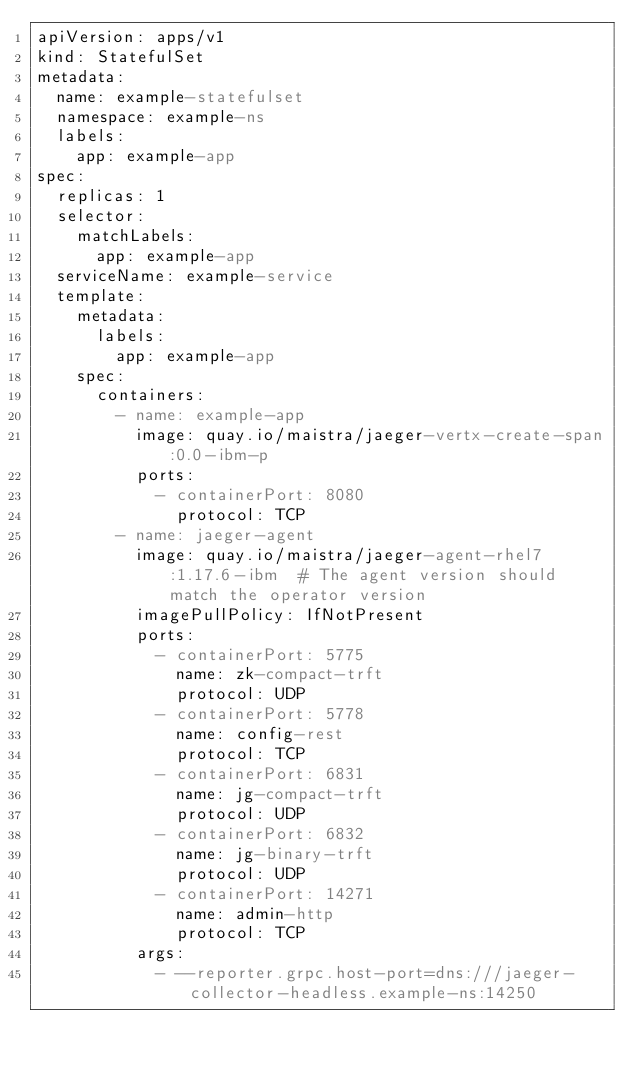Convert code to text. <code><loc_0><loc_0><loc_500><loc_500><_YAML_>apiVersion: apps/v1
kind: StatefulSet
metadata:
  name: example-statefulset
  namespace: example-ns
  labels:
    app: example-app
spec:
  replicas: 1
  selector:
    matchLabels:
      app: example-app
  serviceName: example-service
  template:
    metadata:
      labels:
        app: example-app
    spec:
      containers:
        - name: example-app
          image: quay.io/maistra/jaeger-vertx-create-span:0.0-ibm-p
          ports:
            - containerPort: 8080
              protocol: TCP
        - name: jaeger-agent
          image: quay.io/maistra/jaeger-agent-rhel7:1.17.6-ibm  # The agent version should match the operator version
          imagePullPolicy: IfNotPresent
          ports:
            - containerPort: 5775
              name: zk-compact-trft
              protocol: UDP
            - containerPort: 5778
              name: config-rest
              protocol: TCP
            - containerPort: 6831
              name: jg-compact-trft
              protocol: UDP
            - containerPort: 6832
              name: jg-binary-trft
              protocol: UDP
            - containerPort: 14271
              name: admin-http
              protocol: TCP
          args:
            - --reporter.grpc.host-port=dns:///jaeger-collector-headless.example-ns:14250
</code> 